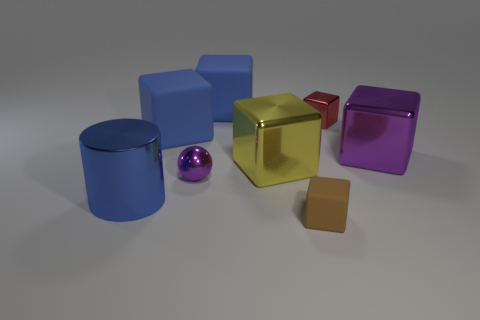What size is the shiny cylinder on the left side of the large purple metal object?
Your answer should be compact. Large. Do the yellow block and the brown rubber object have the same size?
Provide a short and direct response. No. How many things are big yellow blocks or big blue cubes that are in front of the red metal cube?
Offer a very short reply. 2. What is the tiny brown cube made of?
Offer a terse response. Rubber. Are there any other things that have the same color as the metallic cylinder?
Ensure brevity in your answer.  Yes. Does the red metal object have the same shape as the small purple thing?
Offer a terse response. No. There is a purple thing that is to the left of the brown thing right of the large blue thing that is in front of the big yellow metallic cube; how big is it?
Your answer should be compact. Small. How many other objects are the same material as the tiny red thing?
Your response must be concise. 4. There is a small metallic thing that is on the right side of the tiny purple metallic sphere; what is its color?
Ensure brevity in your answer.  Red. There is a tiny thing behind the purple shiny object behind the big shiny block left of the tiny brown matte thing; what is its material?
Your response must be concise. Metal. 